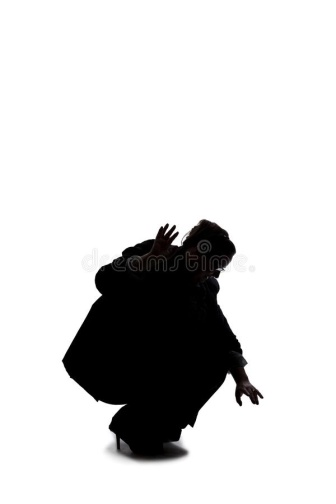If this image were a scene in a dance performance, how would the dance progress from this moment? As the beat of the music intensifies, the figure in the image begins to move with deliberate fluidity, their crouched position gradually transforming into a series of powerful, sweeping motions. They rise slowly, unfurling their body like a coiled spring released. Each movement is meticulously choreographed, blending elements of modern dance with martial arts-inspired gestures. The arms, initially outstretched like claws, transition into wide, encompassing arcs, as if reaching out to embrace the vastness around them. Their feet, initially planted firmly on the ground, begin a rhythmic sequence of steps that mirrors the mounting tension in the music. The dance reaches its crescendo with the figure leaping and spinning, embodying a dynamic balance between grace and raw power. The minimalist backdrop emphasizes each motion, making every gesture more pronounced and emotionally compelling, leading the audience through a visual and auditory journey of suspense, energy, and resolution. 